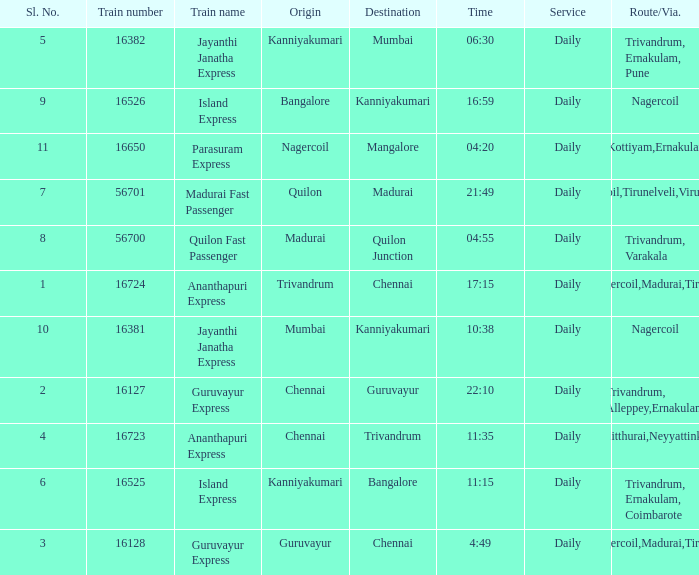What is the destination when the train number is 16526? Kanniyakumari. 